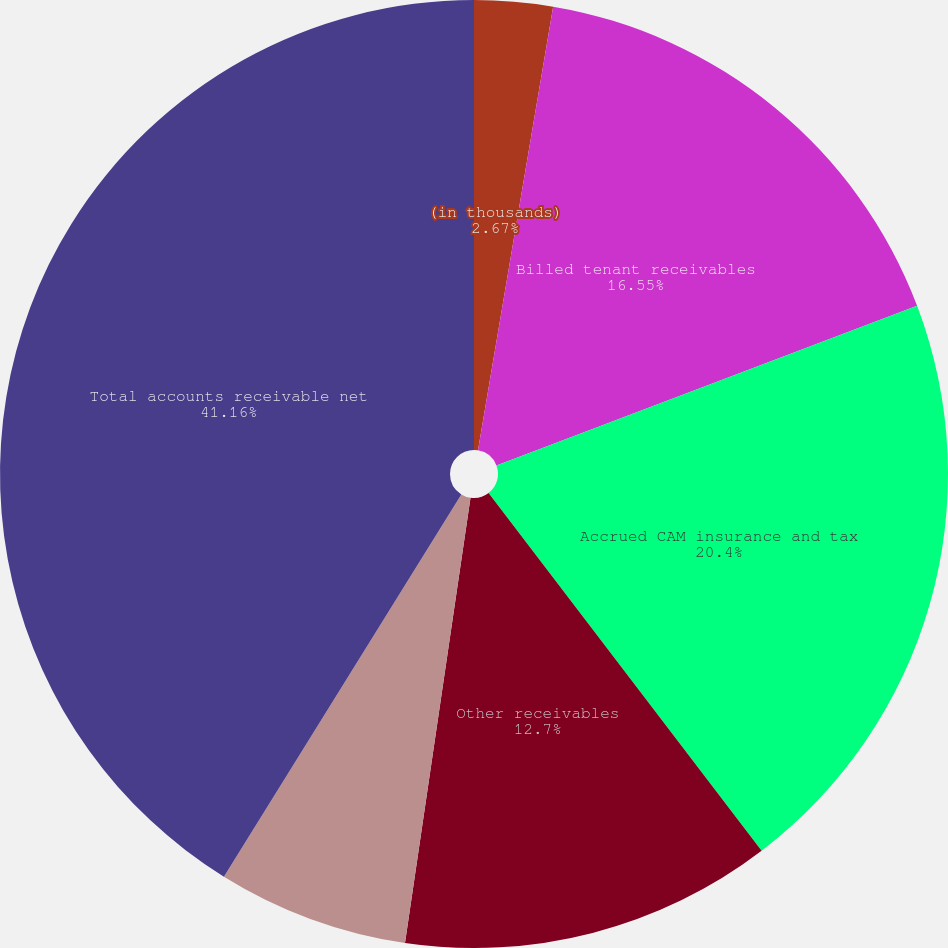<chart> <loc_0><loc_0><loc_500><loc_500><pie_chart><fcel>(in thousands)<fcel>Billed tenant receivables<fcel>Accrued CAM insurance and tax<fcel>Other receivables<fcel>Less allowance for doubtful<fcel>Total accounts receivable net<nl><fcel>2.67%<fcel>16.55%<fcel>20.4%<fcel>12.7%<fcel>6.52%<fcel>41.15%<nl></chart> 